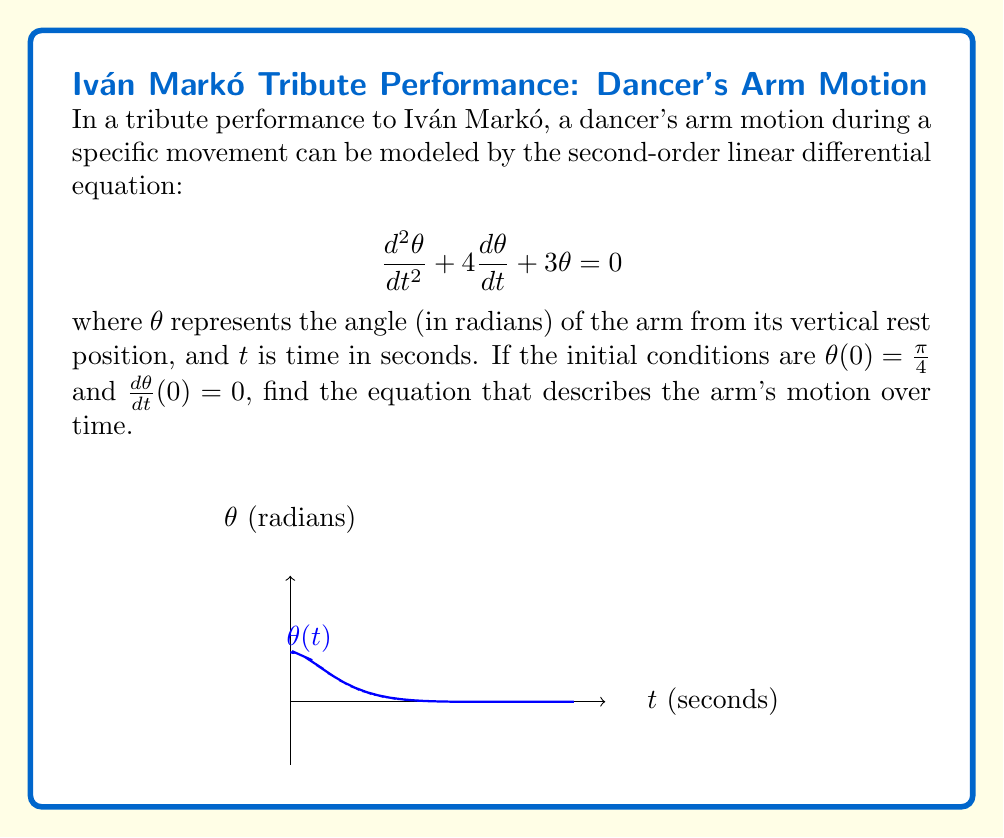Teach me how to tackle this problem. Let's solve this step-by-step:

1) The characteristic equation for this differential equation is:
   $$r^2 + 4r + 3 = 0$$

2) Solving this quadratic equation:
   $$r = \frac{-4 \pm \sqrt{16 - 12}}{2} = \frac{-4 \pm \sqrt{4}}{2} = -2 \pm 1$$

3) The roots are $r_1 = -1$ and $r_2 = -3$, so the general solution is:
   $$\theta(t) = c_1e^{-t} + c_2e^{-3t}$$

4) To find $c_1$ and $c_2$, we use the initial conditions:
   
   From $\theta(0) = \frac{\pi}{4}$:
   $$\frac{\pi}{4} = c_1 + c_2$$

   From $\frac{d\theta}{dt}(0) = 0$:
   $$0 = -c_1 - 3c_2$$

5) Solving these equations:
   $$c_1 = \frac{3\pi}{8}, c_2 = -\frac{\pi}{8}$$

6) Therefore, the solution is:
   $$\theta(t) = \frac{3\pi}{8}e^{-t} - \frac{\pi}{8}e^{-3t}$$

7) This can be rewritten using the identity $e^{-at}(A\cos(bt) + B\sin(bt))$:
   $$\theta(t) = \frac{\pi}{4}e^{-2t}(\cos(t) + 2\sin(t))$$
Answer: $\theta(t) = \frac{\pi}{4}e^{-2t}(\cos(t) + 2\sin(t))$ 